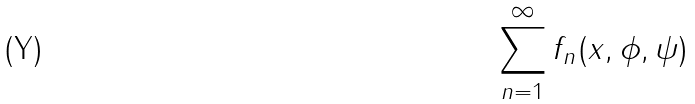Convert formula to latex. <formula><loc_0><loc_0><loc_500><loc_500>\sum _ { n = 1 } ^ { \infty } f _ { n } ( x , \phi , \psi )</formula> 